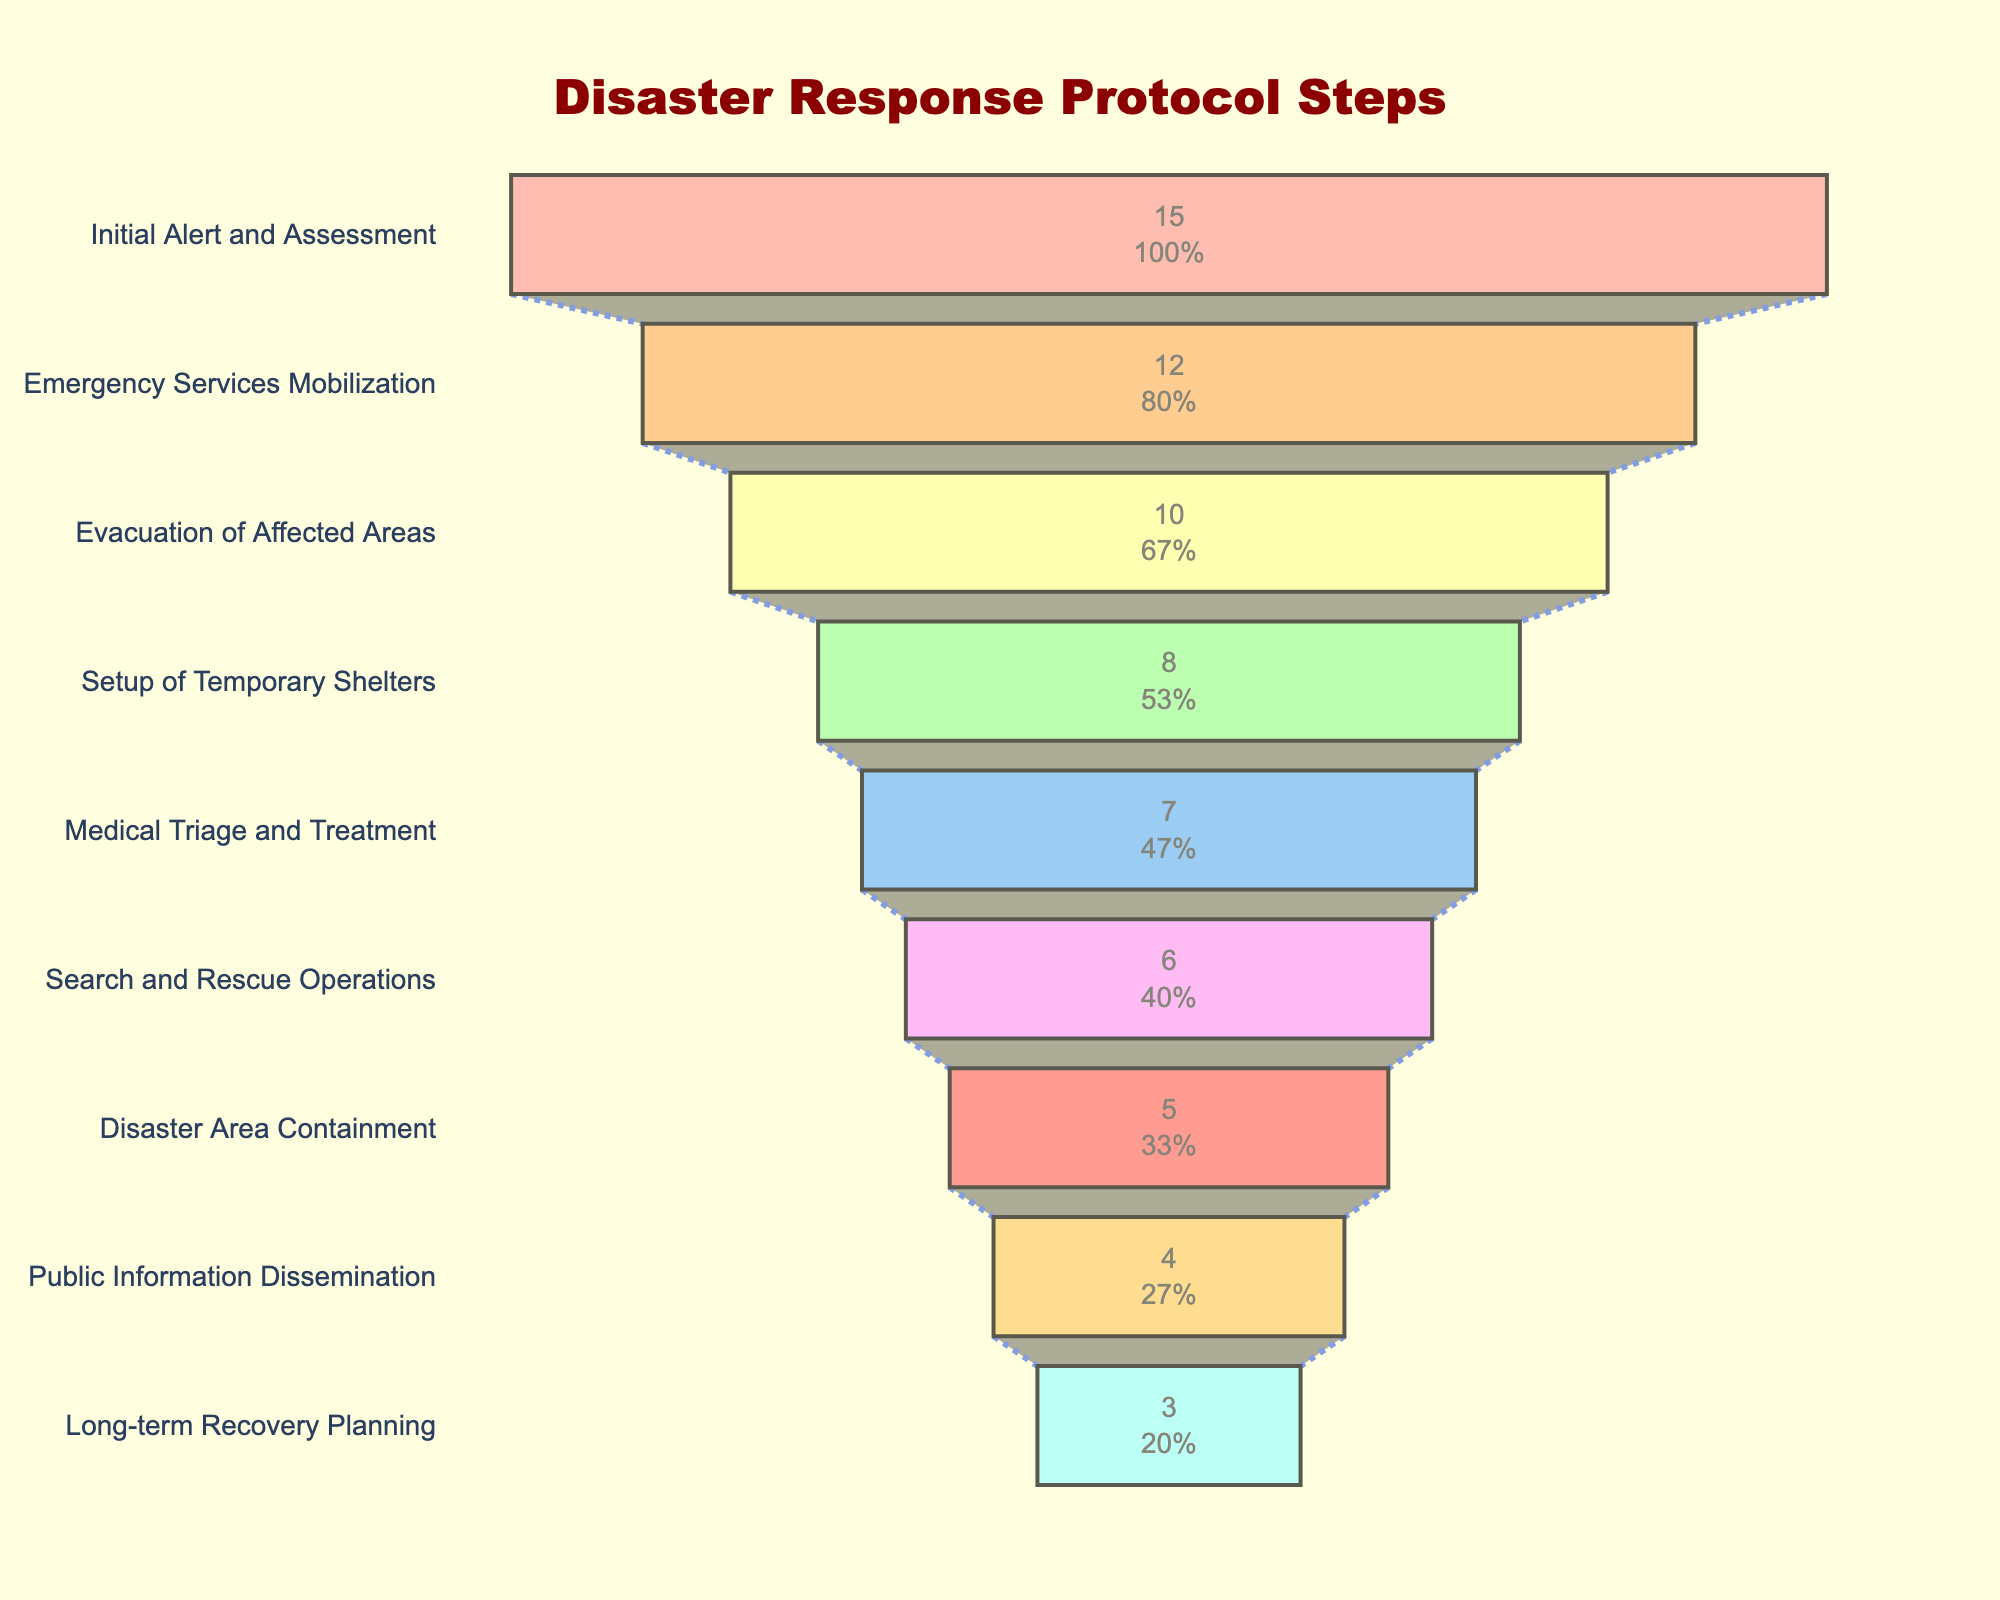What is the title of the chart? The title is located at the top of the chart and is styled in a large, dark red font. It concisely describes the content being displayed.
Answer: Disaster Response Protocol Steps How many total steps are included in the disaster response protocol? By counting the distinct entries listed on the y-axis of the chart, each representing a step, we can determine the total number of steps in the protocol.
Answer: 9 Which step has the highest number of actions? The largest segment at the top of the funnel represents the step with the highest number of actions. The size of the segment corresponds to the number of actions.
Answer: Initial Alert and Assessment How many actions are involved in both the "Medical Triage and Treatment" and the "Search and Rescue Operations" combined? We find the number of actions for "Medical Triage and Treatment" and "Search and Rescue Operations" from their respective funnel segments, and then sum them.
Answer: 7 + 6 = 13 Which step has fewer actions: "Setup of Temporary Shelters" or "Disaster Area Containment"? By comparing the sizes of the segments corresponding to these two steps, we can see which step has a smaller number of actions.
Answer: Disaster Area Containment What percentage of the initial total actions does the "Public Information Dissemination" step represent? We identify the segment for "Public Information Dissemination" and find the percentage value displayed within the segment, which represents its proportion of the total number of actions.
Answer: 4/15 = 26.67% How many steps have less than 10 actions associated with them? By looking at the number of actions for each step, we count all steps where the number of actions is less than 10.
Answer: 6 steps Which step follows immediately after "Emergency Services Mobilization"? The vertical arrangement of the segments specifies the order of the steps. By identifying the segment directly below "Emergency Services Mobilization," we find the next step.
Answer: Evacuation of Affected Areas What is the difference in the number of actions between the step with the highest and the lowest number of actions? We subtract the number of actions in the "Long-term Recovery Planning" step (smallest) from the number in the "Initial Alert and Assessment" step (largest).
Answer: 15 - 3 = 12 